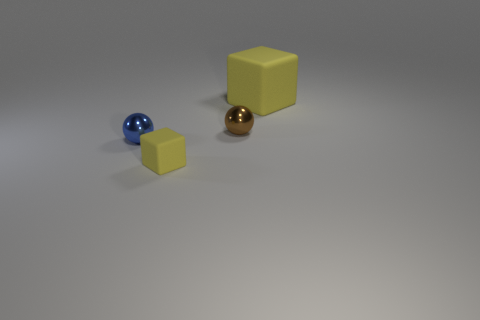Do the yellow object in front of the tiny blue thing and the cube behind the tiny yellow rubber object have the same size?
Your answer should be very brief. No. What size is the blue shiny object that is the same shape as the brown object?
Offer a terse response. Small. Is the number of tiny cubes that are behind the tiny yellow cube greater than the number of matte cubes on the right side of the small brown shiny thing?
Provide a short and direct response. No. There is a object that is both on the left side of the big object and behind the tiny blue sphere; what is its material?
Keep it short and to the point. Metal. The other small object that is the same shape as the blue metallic thing is what color?
Your answer should be very brief. Brown. What size is the brown ball?
Give a very brief answer. Small. What color is the rubber cube that is in front of the rubber object that is behind the tiny brown thing?
Offer a very short reply. Yellow. How many things are behind the tiny blue metallic sphere and in front of the big cube?
Your answer should be very brief. 1. Are there more small matte things than big green matte spheres?
Provide a short and direct response. Yes. What is the material of the tiny blue object?
Keep it short and to the point. Metal. 